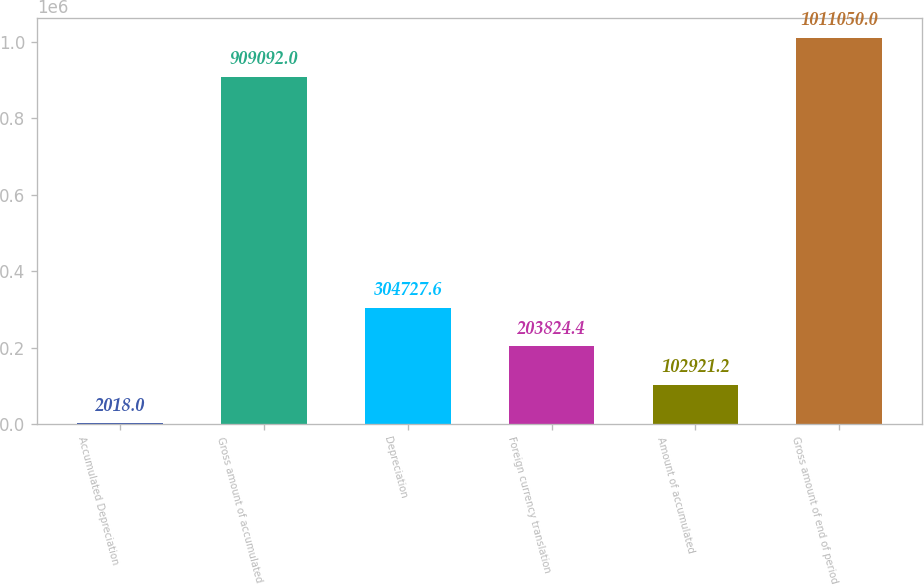Convert chart to OTSL. <chart><loc_0><loc_0><loc_500><loc_500><bar_chart><fcel>Accumulated Depreciation<fcel>Gross amount of accumulated<fcel>Depreciation<fcel>Foreign currency translation<fcel>Amount of accumulated<fcel>Gross amount of end of period<nl><fcel>2018<fcel>909092<fcel>304728<fcel>203824<fcel>102921<fcel>1.01105e+06<nl></chart> 